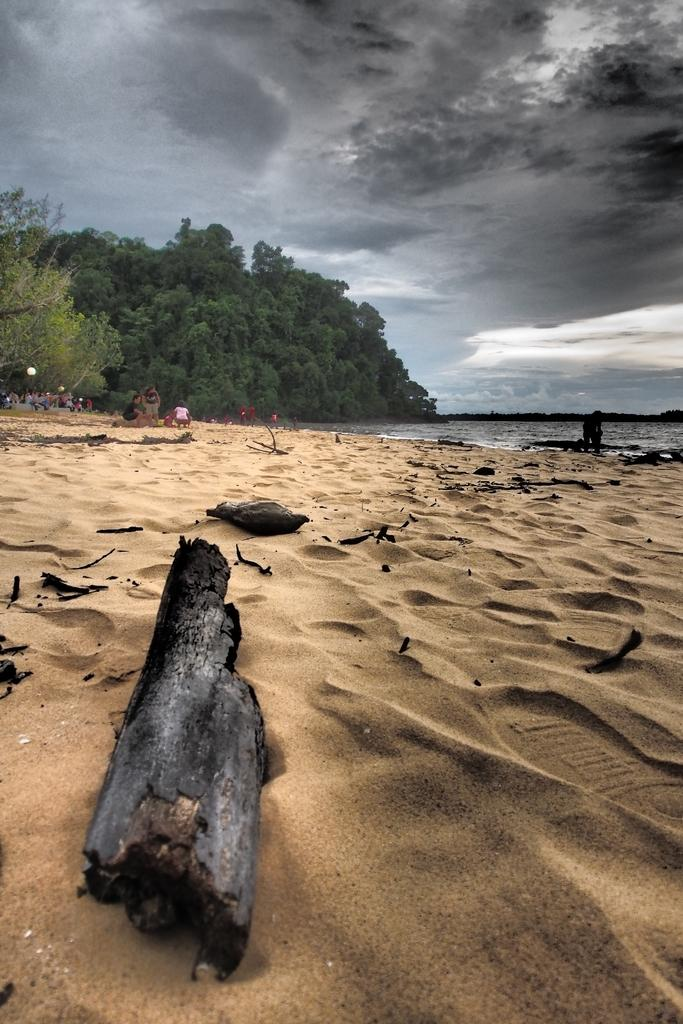What type of natural environment is depicted in the image? The image features water, sand, wooden logs, people, trees, and clouds, which suggests a beach or coastal setting. What type of material are the logs made of? The logs in the image are made of wood. Can you describe the sky in the image? The sky in the image has clouds visible. What type of vegetation can be seen in the image? Trees are visible in the image. What type of growth can be seen on the rat in the image? There is no rat present in the image, so it is not possible to determine what type of growth might be observed. 